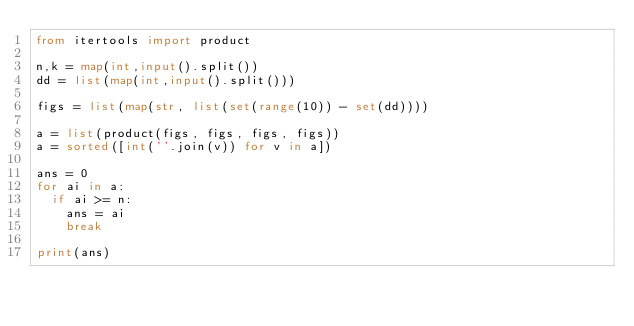Convert code to text. <code><loc_0><loc_0><loc_500><loc_500><_Python_>from itertools import product

n,k = map(int,input().split())
dd = list(map(int,input().split()))

figs = list(map(str, list(set(range(10)) - set(dd))))

a = list(product(figs, figs, figs, figs))
a = sorted([int(''.join(v)) for v in a])
  
ans = 0
for ai in a:
  if ai >= n:
    ans = ai
    break
    
print(ans)</code> 